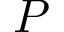Convert formula to latex. <formula><loc_0><loc_0><loc_500><loc_500>P</formula> 